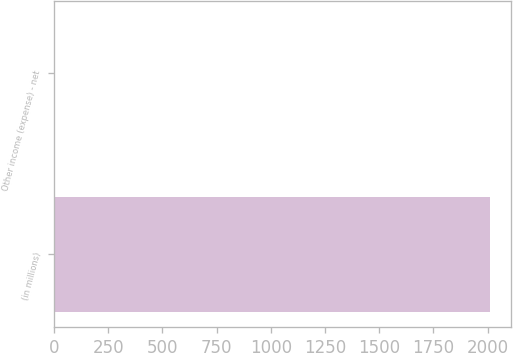<chart> <loc_0><loc_0><loc_500><loc_500><bar_chart><fcel>(in millions)<fcel>Other income (expense) - net<nl><fcel>2010<fcel>2<nl></chart> 